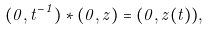<formula> <loc_0><loc_0><loc_500><loc_500>( 0 , t ^ { - 1 } ) * ( 0 , z ) = ( 0 , z ( t ) ) ,</formula> 